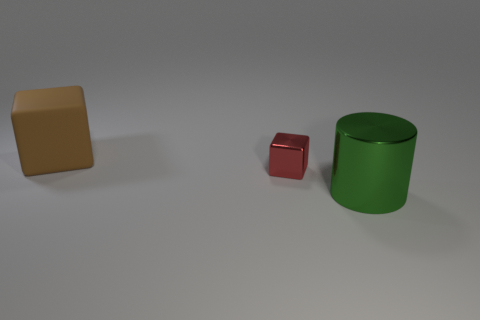Add 3 big brown matte blocks. How many objects exist? 6 Subtract all cylinders. How many objects are left? 2 Subtract all large shiny cylinders. Subtract all metallic cubes. How many objects are left? 1 Add 2 green metal objects. How many green metal objects are left? 3 Add 2 large green cylinders. How many large green cylinders exist? 3 Subtract 0 red cylinders. How many objects are left? 3 